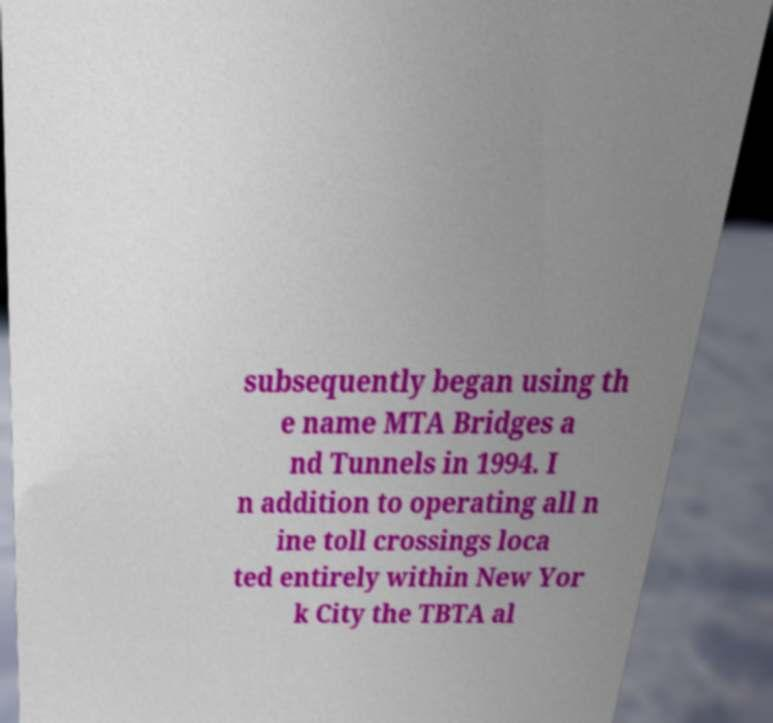Can you read and provide the text displayed in the image?This photo seems to have some interesting text. Can you extract and type it out for me? subsequently began using th e name MTA Bridges a nd Tunnels in 1994. I n addition to operating all n ine toll crossings loca ted entirely within New Yor k City the TBTA al 